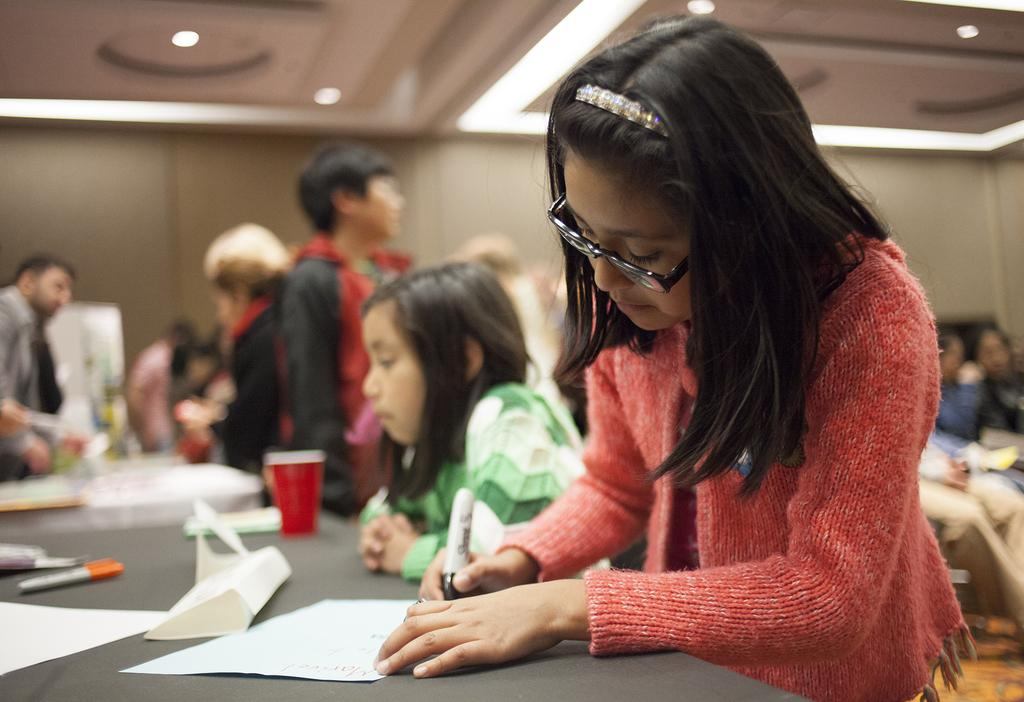Where was the image taken? The image was taken inside a room. What can be seen in the middle of the room? There are persons in the middle of the room. What is located at the bottom of the room? There is a table at the bottom of the room. What items are on the table? Glass, papers, and pens are present on the table. What is visible at the top of the room? There are lights at the top of the room. What type of form is being filled out by the committee in the image? There is no committee or form present in the image; it only shows persons, a table, and items on the table. 